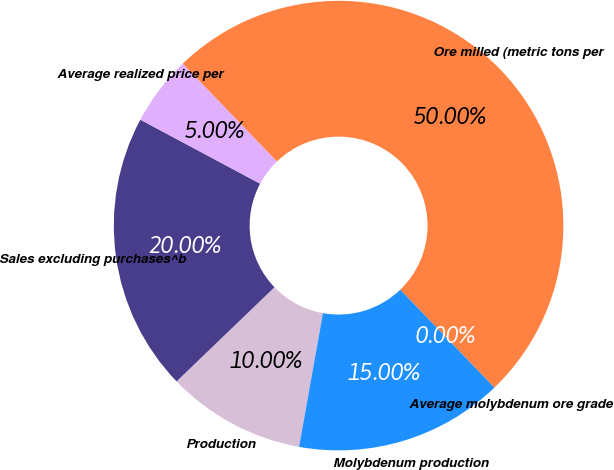Convert chart to OTSL. <chart><loc_0><loc_0><loc_500><loc_500><pie_chart><fcel>Production<fcel>Sales excluding purchases^b<fcel>Average realized price per<fcel>Ore milled (metric tons per<fcel>Average molybdenum ore grade<fcel>Molybdenum production<nl><fcel>10.0%<fcel>20.0%<fcel>5.0%<fcel>50.0%<fcel>0.0%<fcel>15.0%<nl></chart> 